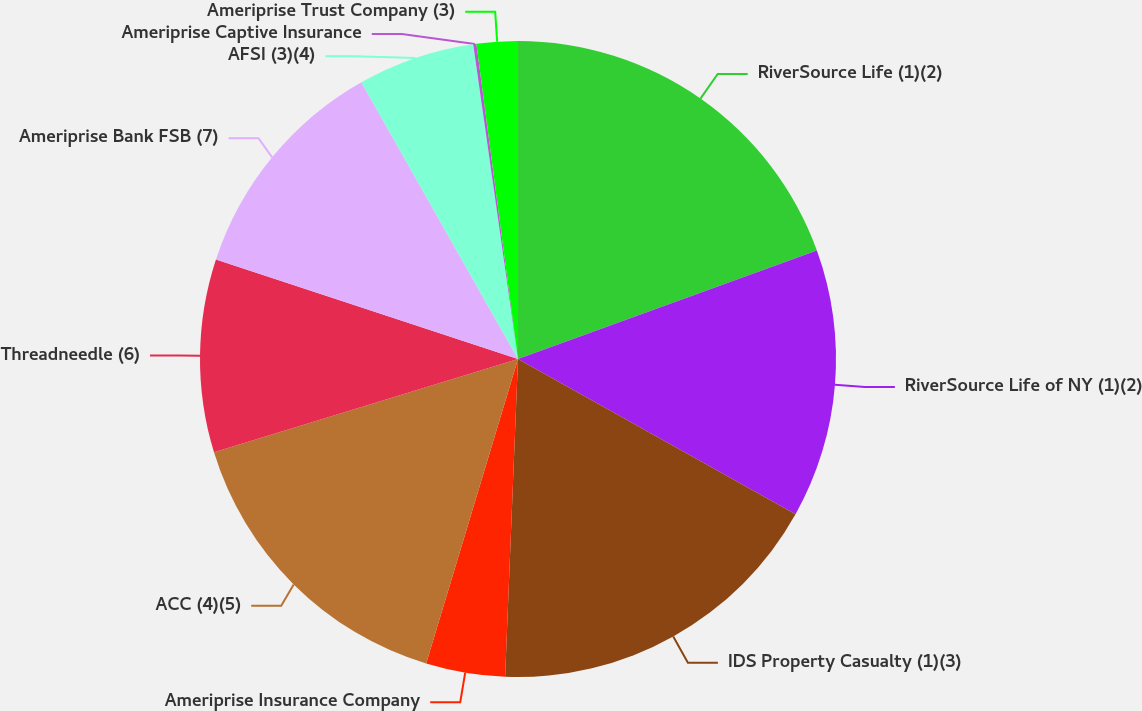Convert chart. <chart><loc_0><loc_0><loc_500><loc_500><pie_chart><fcel>RiverSource Life (1)(2)<fcel>RiverSource Life of NY (1)(2)<fcel>IDS Property Casualty (1)(3)<fcel>Ameriprise Insurance Company<fcel>ACC (4)(5)<fcel>Threadneedle (6)<fcel>Ameriprise Bank FSB (7)<fcel>AFSI (3)(4)<fcel>Ameriprise Captive Insurance<fcel>Ameriprise Trust Company (3)<nl><fcel>19.46%<fcel>13.67%<fcel>17.53%<fcel>4.02%<fcel>15.6%<fcel>9.81%<fcel>11.74%<fcel>5.95%<fcel>0.16%<fcel>2.09%<nl></chart> 